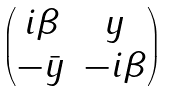<formula> <loc_0><loc_0><loc_500><loc_500>\begin{pmatrix} i \beta & y \\ - \bar { y } & - i \beta \end{pmatrix}</formula> 